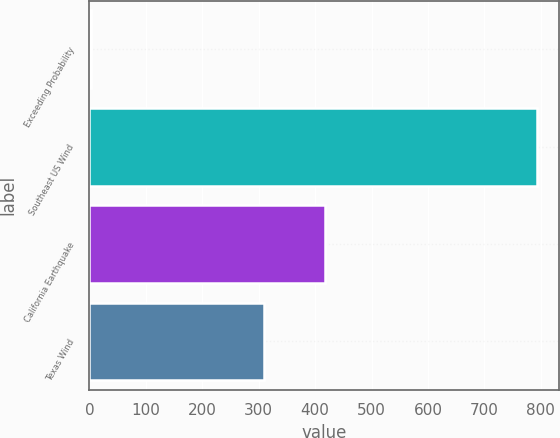Convert chart. <chart><loc_0><loc_0><loc_500><loc_500><bar_chart><fcel>Exceeding Probability<fcel>Southeast US Wind<fcel>California Earthquake<fcel>Texas Wind<nl><fcel>2<fcel>793<fcel>417<fcel>310<nl></chart> 